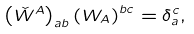<formula> <loc_0><loc_0><loc_500><loc_500>\left ( \check { W } ^ { A } \right ) _ { a b } \left ( W _ { A } \right ) ^ { b c } = \delta _ { a } ^ { c } ,</formula> 